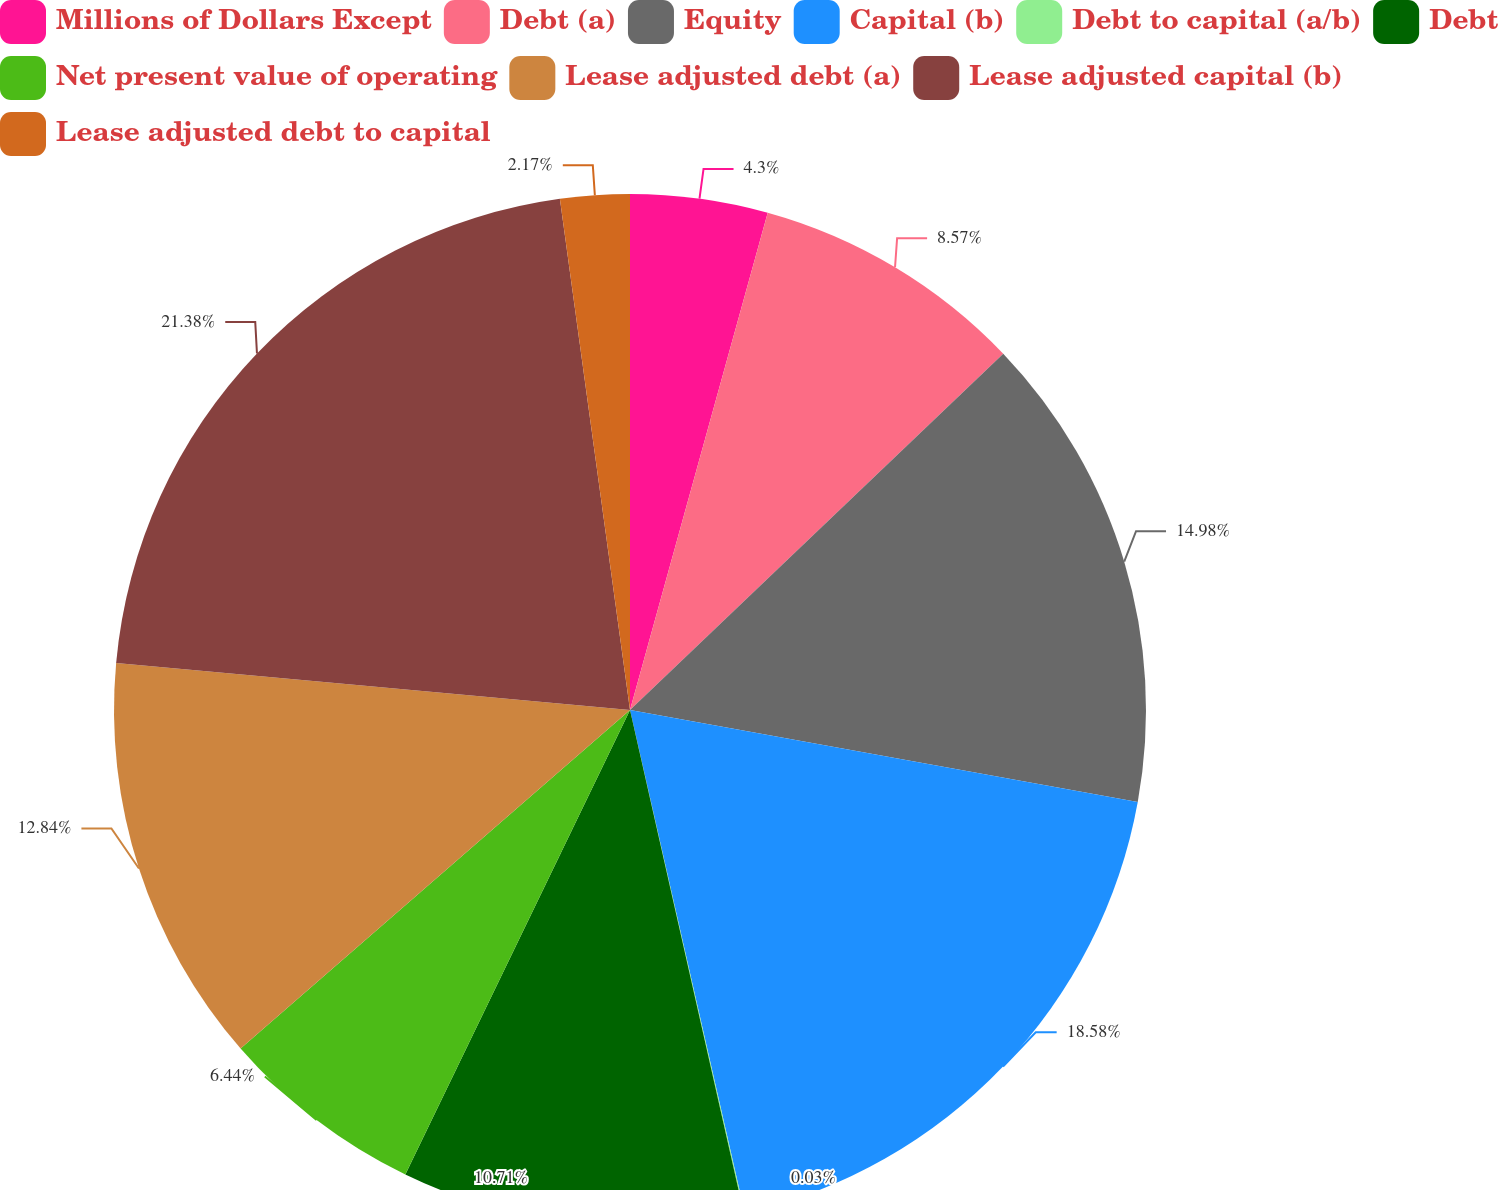Convert chart to OTSL. <chart><loc_0><loc_0><loc_500><loc_500><pie_chart><fcel>Millions of Dollars Except<fcel>Debt (a)<fcel>Equity<fcel>Capital (b)<fcel>Debt to capital (a/b)<fcel>Debt<fcel>Net present value of operating<fcel>Lease adjusted debt (a)<fcel>Lease adjusted capital (b)<fcel>Lease adjusted debt to capital<nl><fcel>4.3%<fcel>8.57%<fcel>14.98%<fcel>18.58%<fcel>0.03%<fcel>10.71%<fcel>6.44%<fcel>12.84%<fcel>21.38%<fcel>2.17%<nl></chart> 